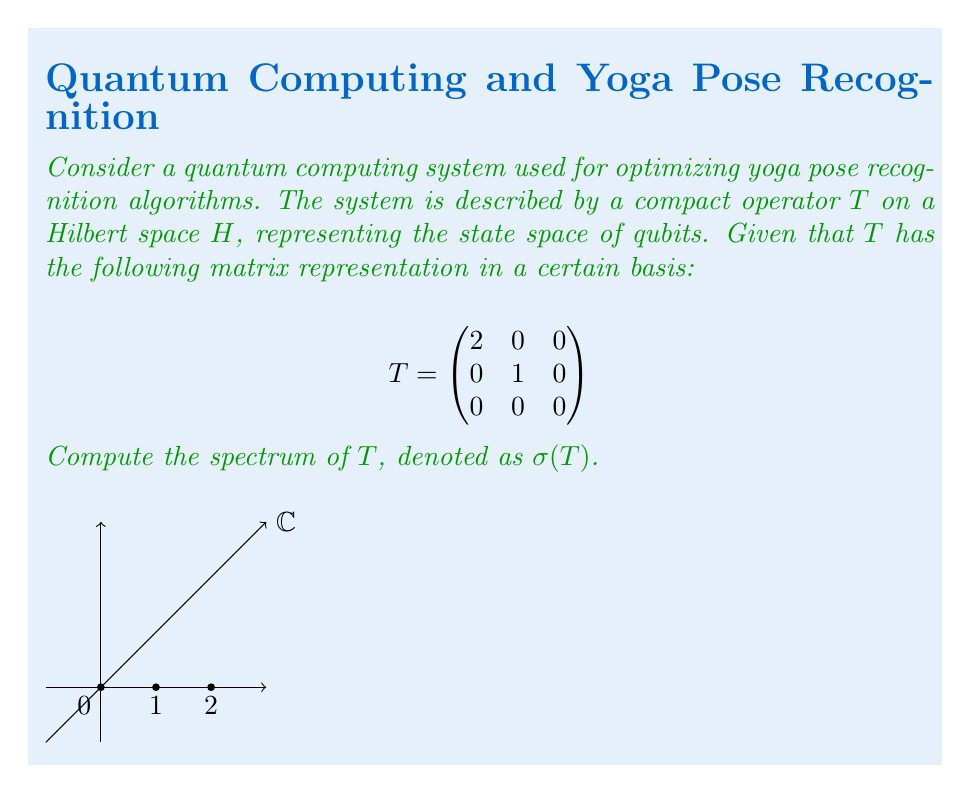Teach me how to tackle this problem. To compute the spectrum of the compact operator $T$, we follow these steps:

1) For a compact operator on a Hilbert space, the spectrum consists of 0 and the eigenvalues of the operator.

2) To find the eigenvalues, we need to solve the characteristic equation:
   $$\det(T - \lambda I) = 0$$

3) Expanding the determinant:
   $$\det\begin{pmatrix}
   2-\lambda & 0 & 0 \\
   0 & 1-\lambda & 0 \\
   0 & 0 & -\lambda
   \end{pmatrix} = 0$$

4) Multiplying the diagonal elements:
   $$(2-\lambda)(1-\lambda)(-\lambda) = 0$$

5) Solving this equation:
   $\lambda = 0$, $\lambda = 1$, or $\lambda = 2$

6) These are the eigenvalues of $T$. Since $T$ is compact, 0 is always in the spectrum even if it's not an eigenvalue.

7) Therefore, the spectrum of $T$ is the set containing 0 and all the eigenvalues:
   $$\sigma(T) = \{0, 1, 2\}$$

This spectrum represents the possible outcomes of energy measurements in the quantum system, which could correspond to different recognized yoga poses in the optimization algorithm.
Answer: $\sigma(T) = \{0, 1, 2\}$ 